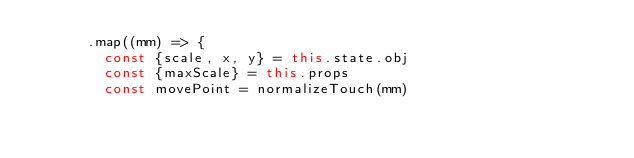Convert code to text. <code><loc_0><loc_0><loc_500><loc_500><_JavaScript_>      .map((mm) => {
        const {scale, x, y} = this.state.obj
        const {maxScale} = this.props
        const movePoint = normalizeTouch(mm)
</code> 